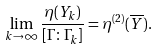Convert formula to latex. <formula><loc_0><loc_0><loc_500><loc_500>\lim _ { k \to \infty } \frac { \eta ( Y _ { k } ) } { [ \Gamma \colon \Gamma _ { k } ] } = \eta ^ { ( 2 ) } ( \overline { Y } ) .</formula> 